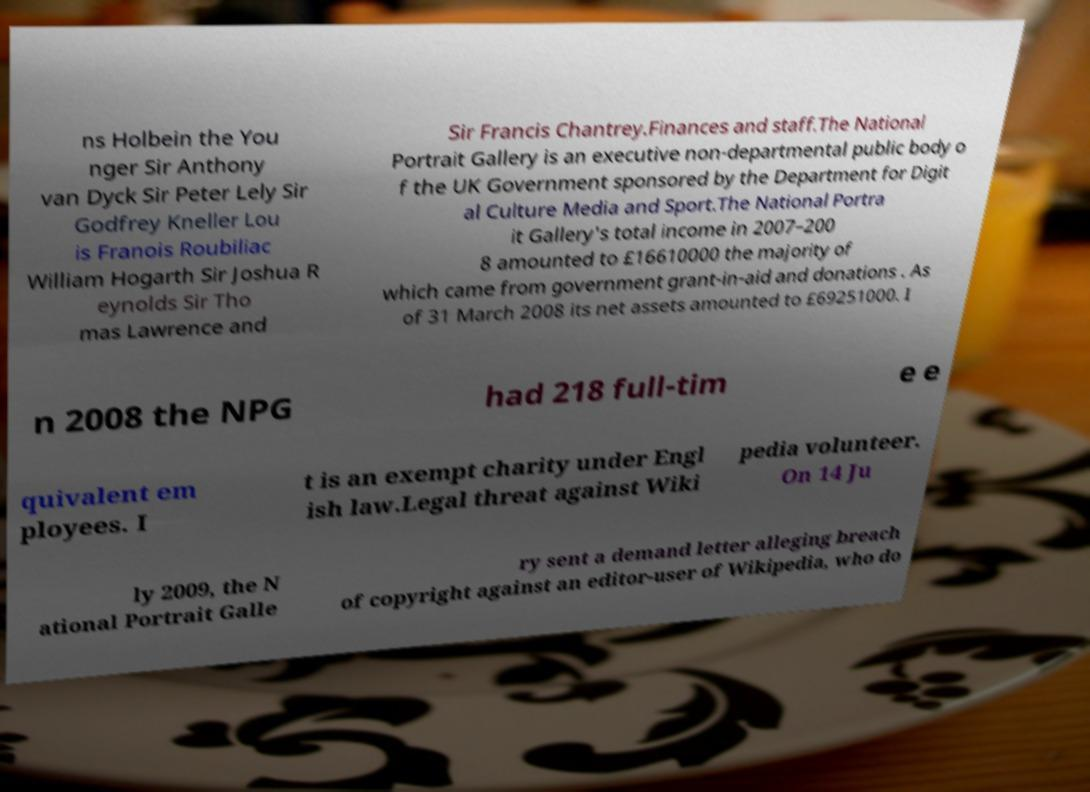For documentation purposes, I need the text within this image transcribed. Could you provide that? ns Holbein the You nger Sir Anthony van Dyck Sir Peter Lely Sir Godfrey Kneller Lou is Franois Roubiliac William Hogarth Sir Joshua R eynolds Sir Tho mas Lawrence and Sir Francis Chantrey.Finances and staff.The National Portrait Gallery is an executive non-departmental public body o f the UK Government sponsored by the Department for Digit al Culture Media and Sport.The National Portra it Gallery's total income in 2007–200 8 amounted to £16610000 the majority of which came from government grant-in-aid and donations . As of 31 March 2008 its net assets amounted to £69251000. I n 2008 the NPG had 218 full-tim e e quivalent em ployees. I t is an exempt charity under Engl ish law.Legal threat against Wiki pedia volunteer. On 14 Ju ly 2009, the N ational Portrait Galle ry sent a demand letter alleging breach of copyright against an editor-user of Wikipedia, who do 